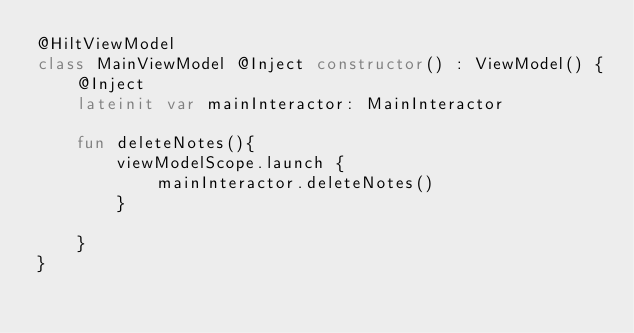<code> <loc_0><loc_0><loc_500><loc_500><_Kotlin_>@HiltViewModel
class MainViewModel @Inject constructor() : ViewModel() {
    @Inject
    lateinit var mainInteractor: MainInteractor

    fun deleteNotes(){
        viewModelScope.launch {
            mainInteractor.deleteNotes()
        }

    }
}</code> 